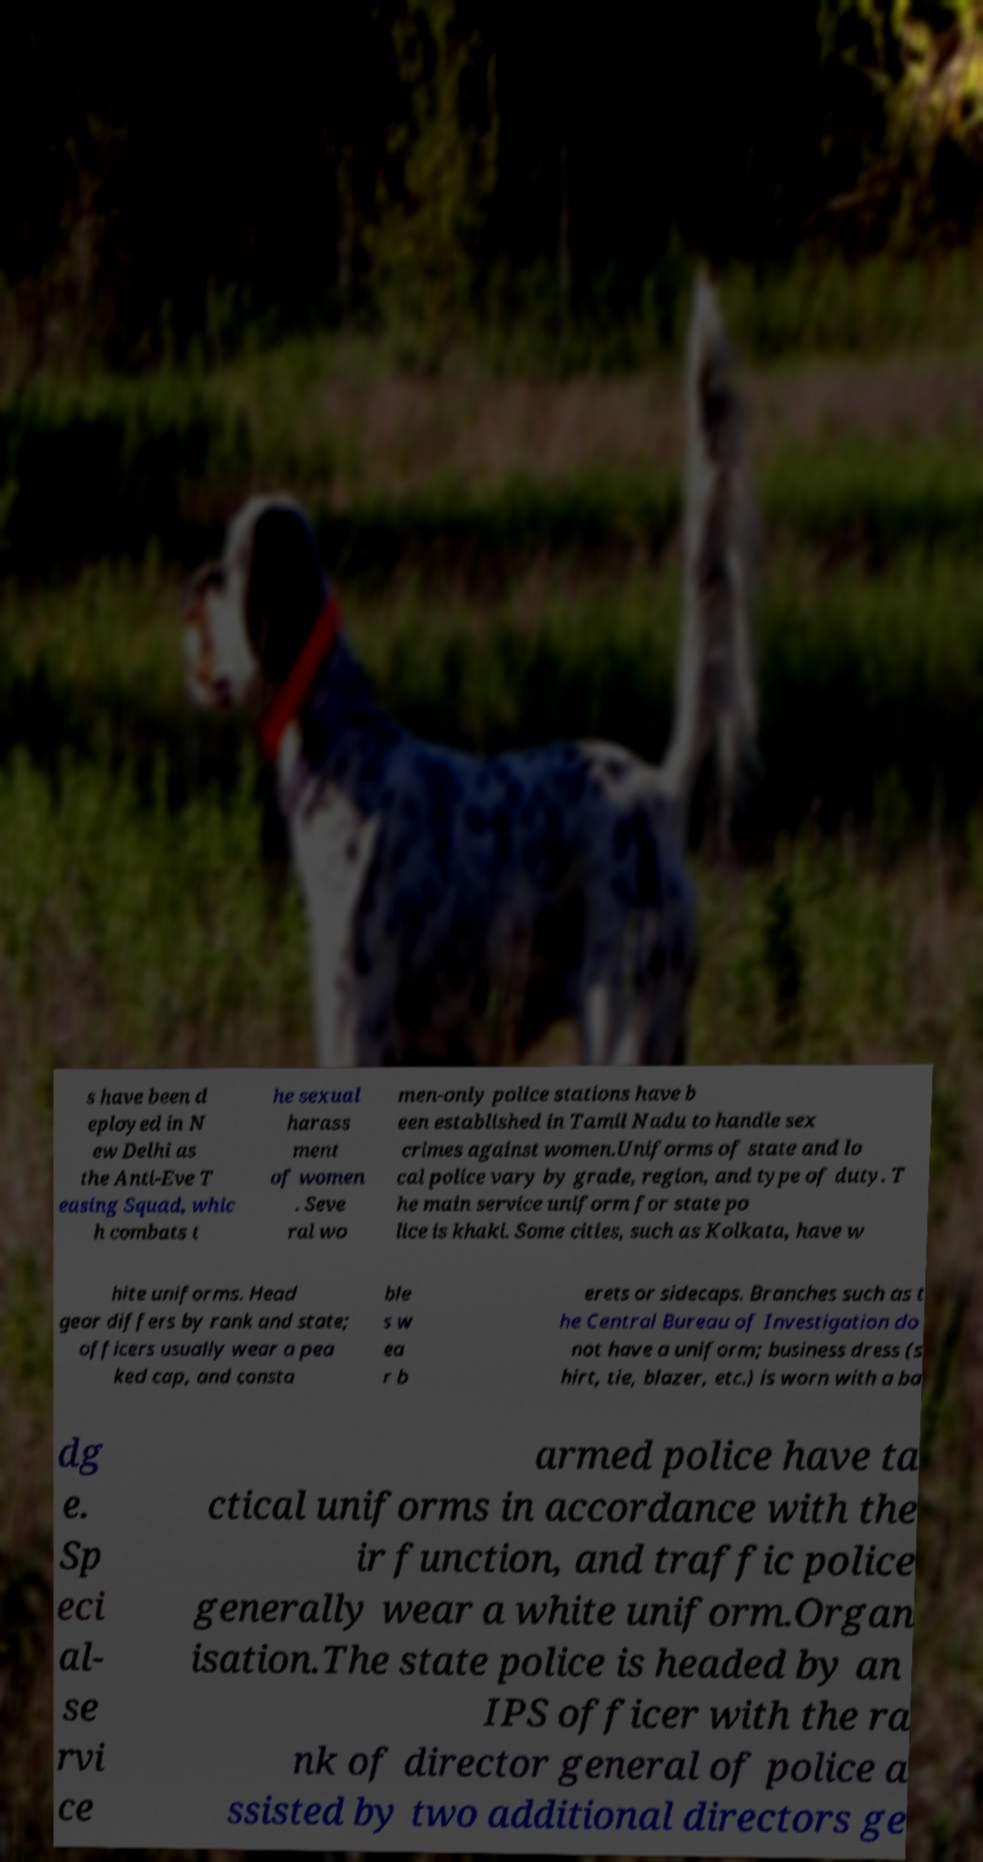I need the written content from this picture converted into text. Can you do that? s have been d eployed in N ew Delhi as the Anti-Eve T easing Squad, whic h combats t he sexual harass ment of women . Seve ral wo men-only police stations have b een established in Tamil Nadu to handle sex crimes against women.Uniforms of state and lo cal police vary by grade, region, and type of duty. T he main service uniform for state po lice is khaki. Some cities, such as Kolkata, have w hite uniforms. Head gear differs by rank and state; officers usually wear a pea ked cap, and consta ble s w ea r b erets or sidecaps. Branches such as t he Central Bureau of Investigation do not have a uniform; business dress (s hirt, tie, blazer, etc.) is worn with a ba dg e. Sp eci al- se rvi ce armed police have ta ctical uniforms in accordance with the ir function, and traffic police generally wear a white uniform.Organ isation.The state police is headed by an IPS officer with the ra nk of director general of police a ssisted by two additional directors ge 